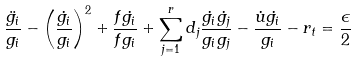<formula> <loc_0><loc_0><loc_500><loc_500>\frac { \ddot { g _ { i } } } { g _ { i } } - \left ( \frac { \dot { g _ { i } } } { g _ { i } } \right ) ^ { 2 } + \frac { f \dot { g _ { i } } } { f g _ { i } } + \sum _ { j = 1 } ^ { r } d _ { j } \frac { \dot { g _ { i } } \dot { g _ { j } } } { g _ { i } g _ { j } } - \frac { \dot { u } \dot { g _ { i } } } { g _ { i } } - r _ { t } = \frac { \epsilon } { 2 }</formula> 